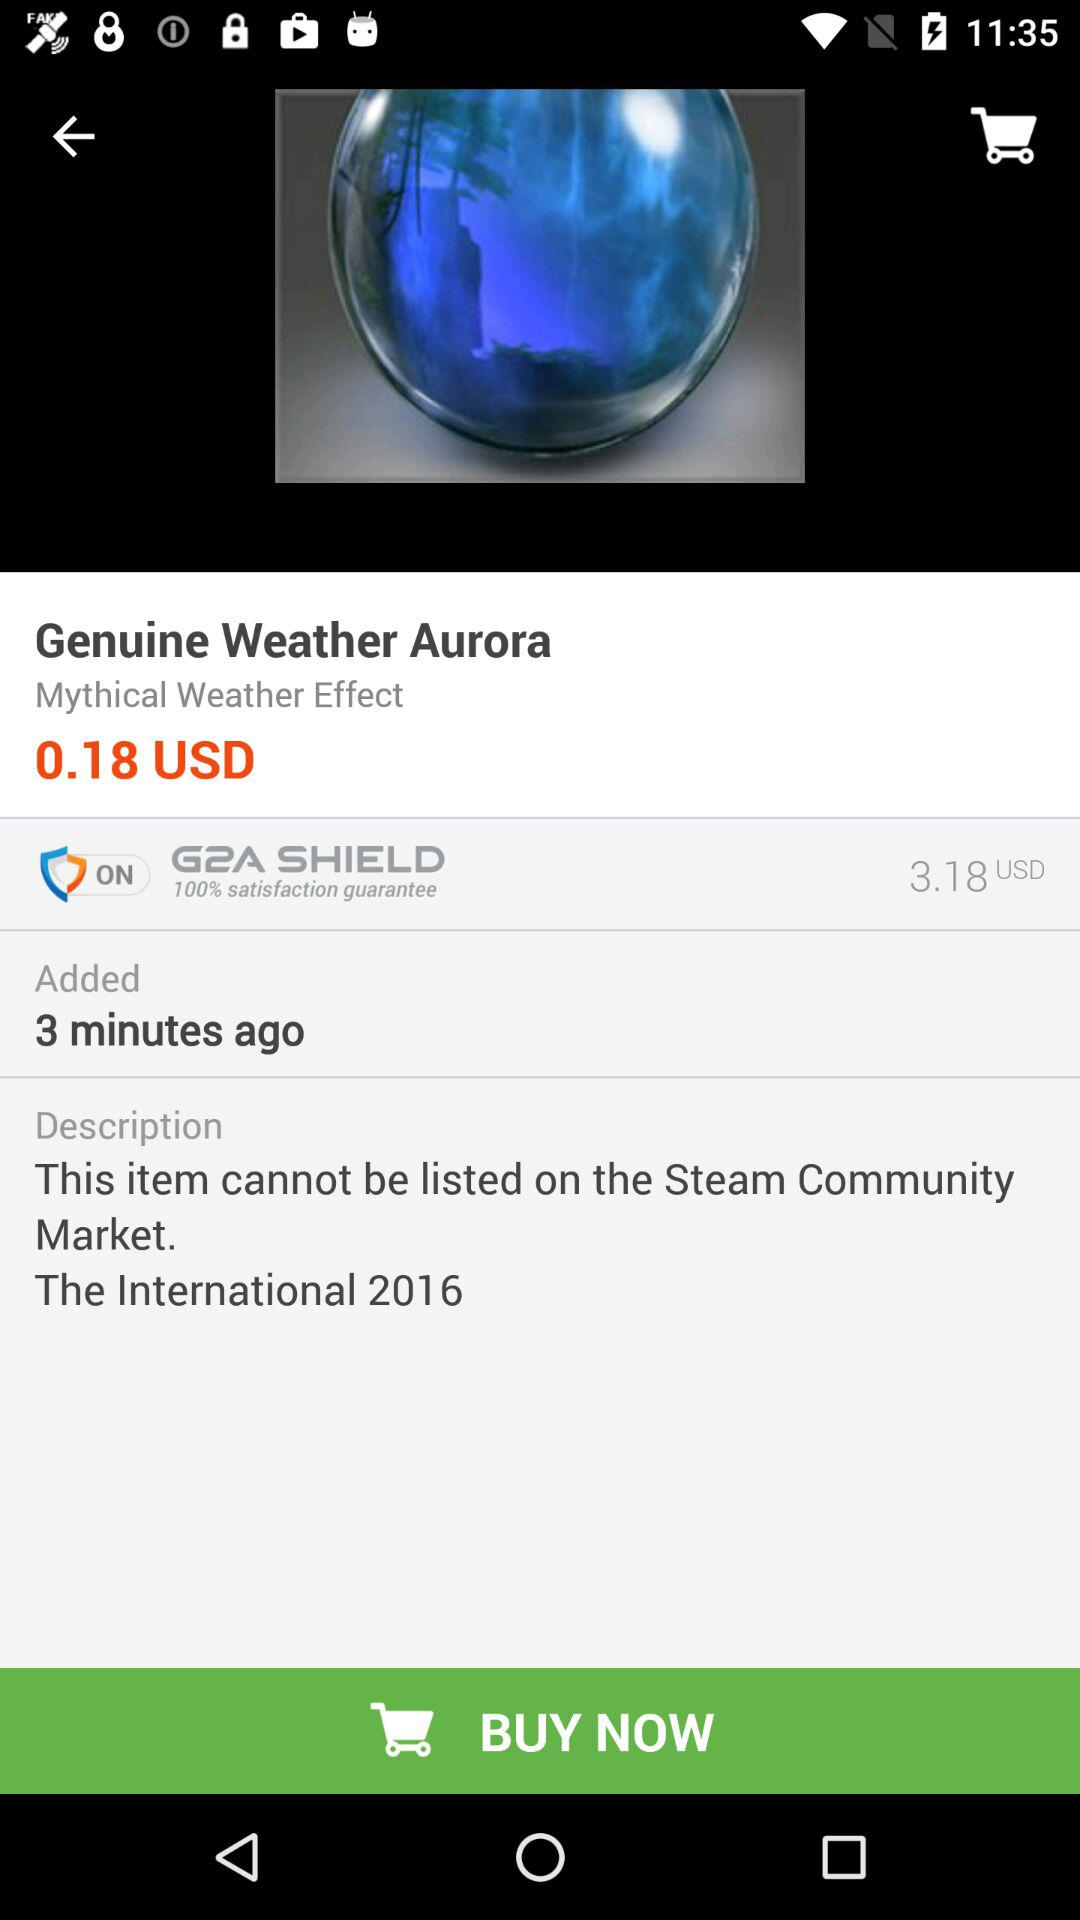What is the price of "Genuine Weather Aurora"? The price of "Genuine Weather Aurora" is 0.18 USD. 